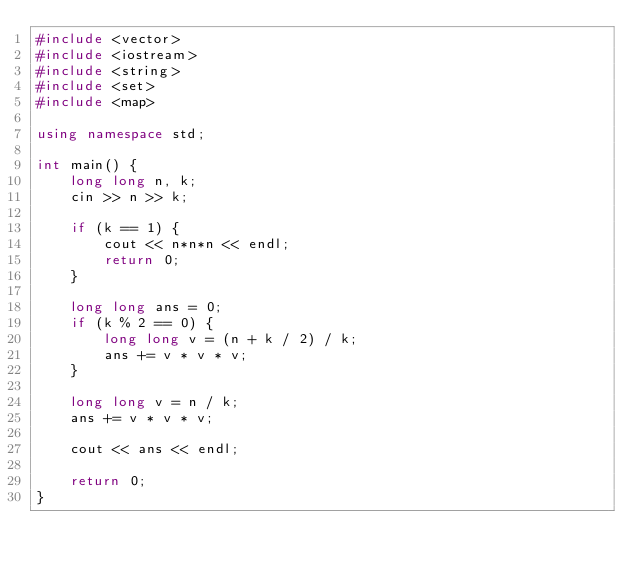Convert code to text. <code><loc_0><loc_0><loc_500><loc_500><_C++_>#include <vector>
#include <iostream>
#include <string>
#include <set>
#include <map>

using namespace std;

int main() {
	long long n, k;
	cin >> n >> k;

	if (k == 1) {
		cout << n*n*n << endl;
		return 0;
	}

	long long ans = 0;
	if (k % 2 == 0) {
		long long v = (n + k / 2) / k;
		ans += v * v * v;
	}

	long long v = n / k;
	ans += v * v * v;

	cout << ans << endl;

	return 0;
}
</code> 